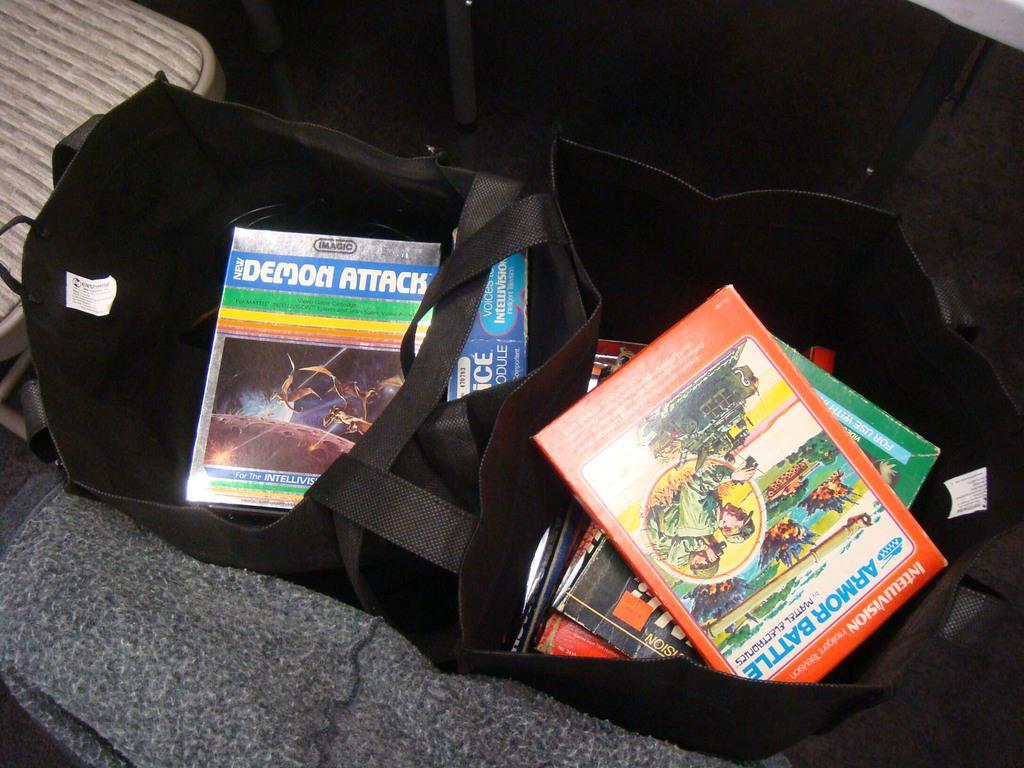How would you summarize this image in a sentence or two? Here I can see a black color bag and few books are placed on a mat. On the left side there is a table. 